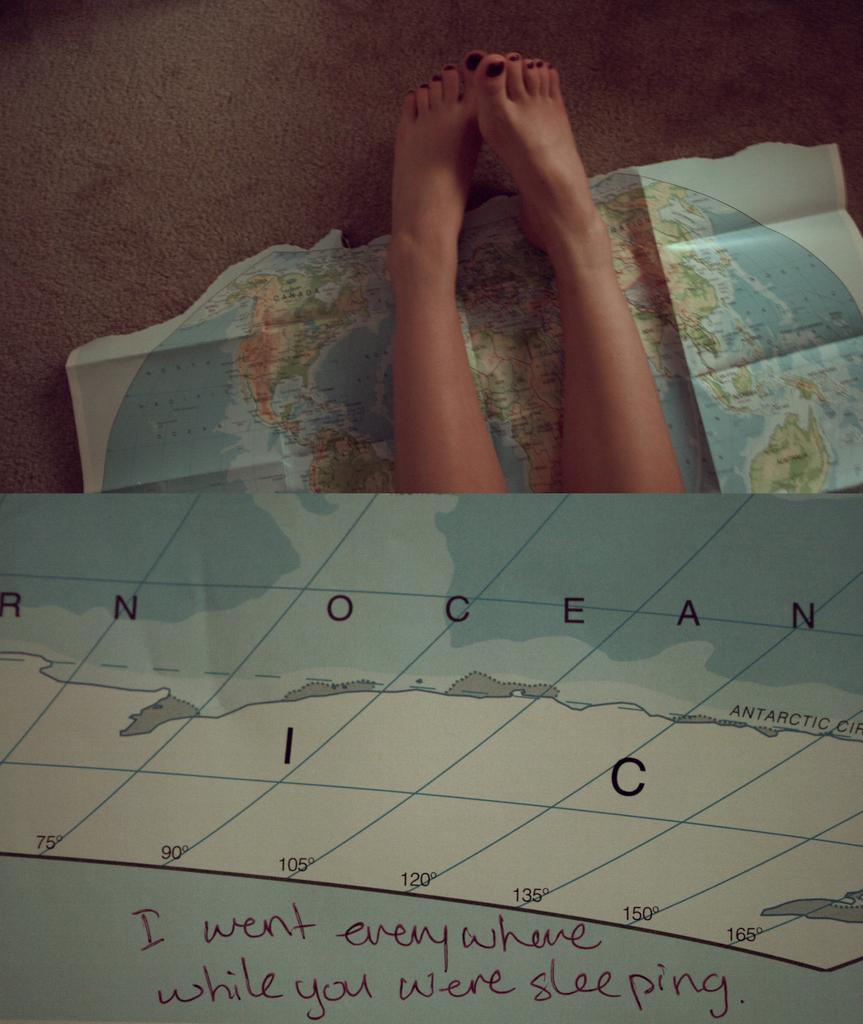Can you describe this image briefly? In the picture I can see a person legs. I can also see map on a paper. Below the image I can see something written over here. 